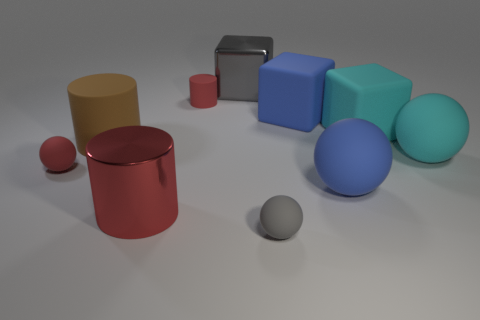Are there any big cylinders?
Make the answer very short. Yes. There is a blue sphere that is the same material as the gray sphere; what is its size?
Provide a short and direct response. Large. Is the big gray thing made of the same material as the tiny gray thing?
Offer a very short reply. No. How many other objects are there of the same material as the large blue cube?
Offer a terse response. 7. How many big objects are in front of the brown rubber thing and behind the red ball?
Provide a short and direct response. 1. The small cylinder is what color?
Offer a terse response. Red. There is a tiny red object that is the same shape as the large brown object; what is its material?
Offer a very short reply. Rubber. Does the metallic cylinder have the same color as the small matte cylinder?
Your response must be concise. Yes. There is a tiny matte thing on the right side of the tiny thing behind the cyan sphere; what is its shape?
Provide a succinct answer. Sphere. The gray object that is made of the same material as the large brown object is what shape?
Your answer should be compact. Sphere. 